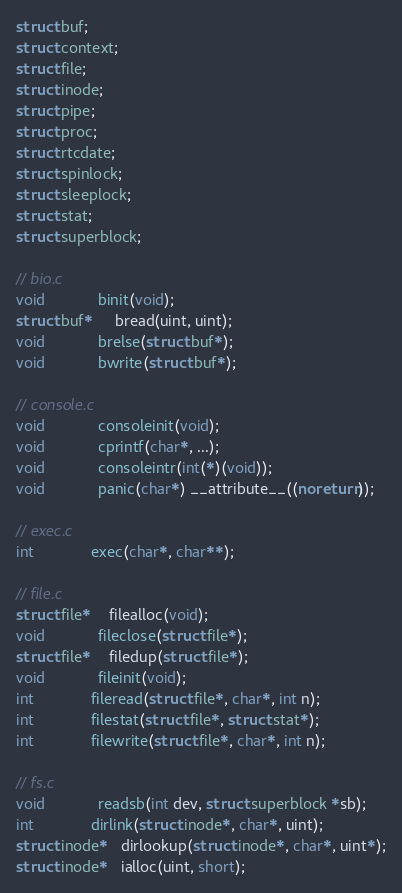Convert code to text. <code><loc_0><loc_0><loc_500><loc_500><_C_>struct buf;
struct context;
struct file;
struct inode;
struct pipe;
struct proc;
struct rtcdate;
struct spinlock;
struct sleeplock;
struct stat;
struct superblock;

// bio.c
void            binit(void);
struct buf*     bread(uint, uint);
void            brelse(struct buf*);
void            bwrite(struct buf*);

// console.c
void            consoleinit(void);
void            cprintf(char*, ...);
void            consoleintr(int(*)(void));
void            panic(char*) __attribute__((noreturn));

// exec.c
int             exec(char*, char**);

// file.c
struct file*    filealloc(void);
void            fileclose(struct file*);
struct file*    filedup(struct file*);
void            fileinit(void);
int             fileread(struct file*, char*, int n);
int             filestat(struct file*, struct stat*);
int             filewrite(struct file*, char*, int n);

// fs.c
void            readsb(int dev, struct superblock *sb);
int             dirlink(struct inode*, char*, uint);
struct inode*   dirlookup(struct inode*, char*, uint*);
struct inode*   ialloc(uint, short);</code> 